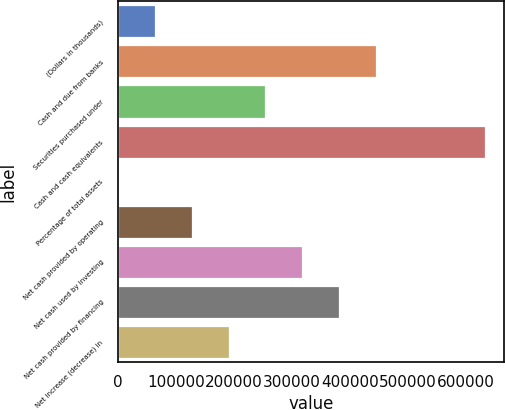Convert chart to OTSL. <chart><loc_0><loc_0><loc_500><loc_500><bar_chart><fcel>(Dollars in thousands)<fcel>Cash and due from banks<fcel>Securities purchased under<fcel>Cash and cash equivalents<fcel>Percentage of total assets<fcel>Net cash provided by operating<fcel>Net cash used by investing<fcel>Net cash provided by financing<fcel>Net increase (decrease) in<nl><fcel>63267.9<fcel>443892<fcel>254120<fcel>632585<fcel>10.5<fcel>127605<fcel>317377<fcel>380635<fcel>190862<nl></chart> 